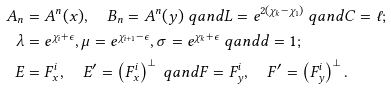<formula> <loc_0><loc_0><loc_500><loc_500>A _ { n } & = A ^ { n } ( x ) , \quad B _ { n } = A ^ { n } ( y ) \ q a n d L = e ^ { 2 ( \chi _ { k } - \chi _ { 1 } ) } \ q a n d C = \ell ; \\ \lambda & = e ^ { \chi _ { i } + \epsilon } , \mu = e ^ { \chi _ { i + 1 } - \epsilon } , \sigma = e ^ { \chi _ { k } + \epsilon } \ q a n d d = 1 ; \\ E & = F ^ { i } _ { x } , \quad E ^ { \prime } = \left ( F ^ { i } _ { x } \right ) ^ { \perp } \ q a n d F = F ^ { i } _ { y } , \quad F ^ { \prime } = \left ( F ^ { i } _ { y } \right ) ^ { \perp } .</formula> 